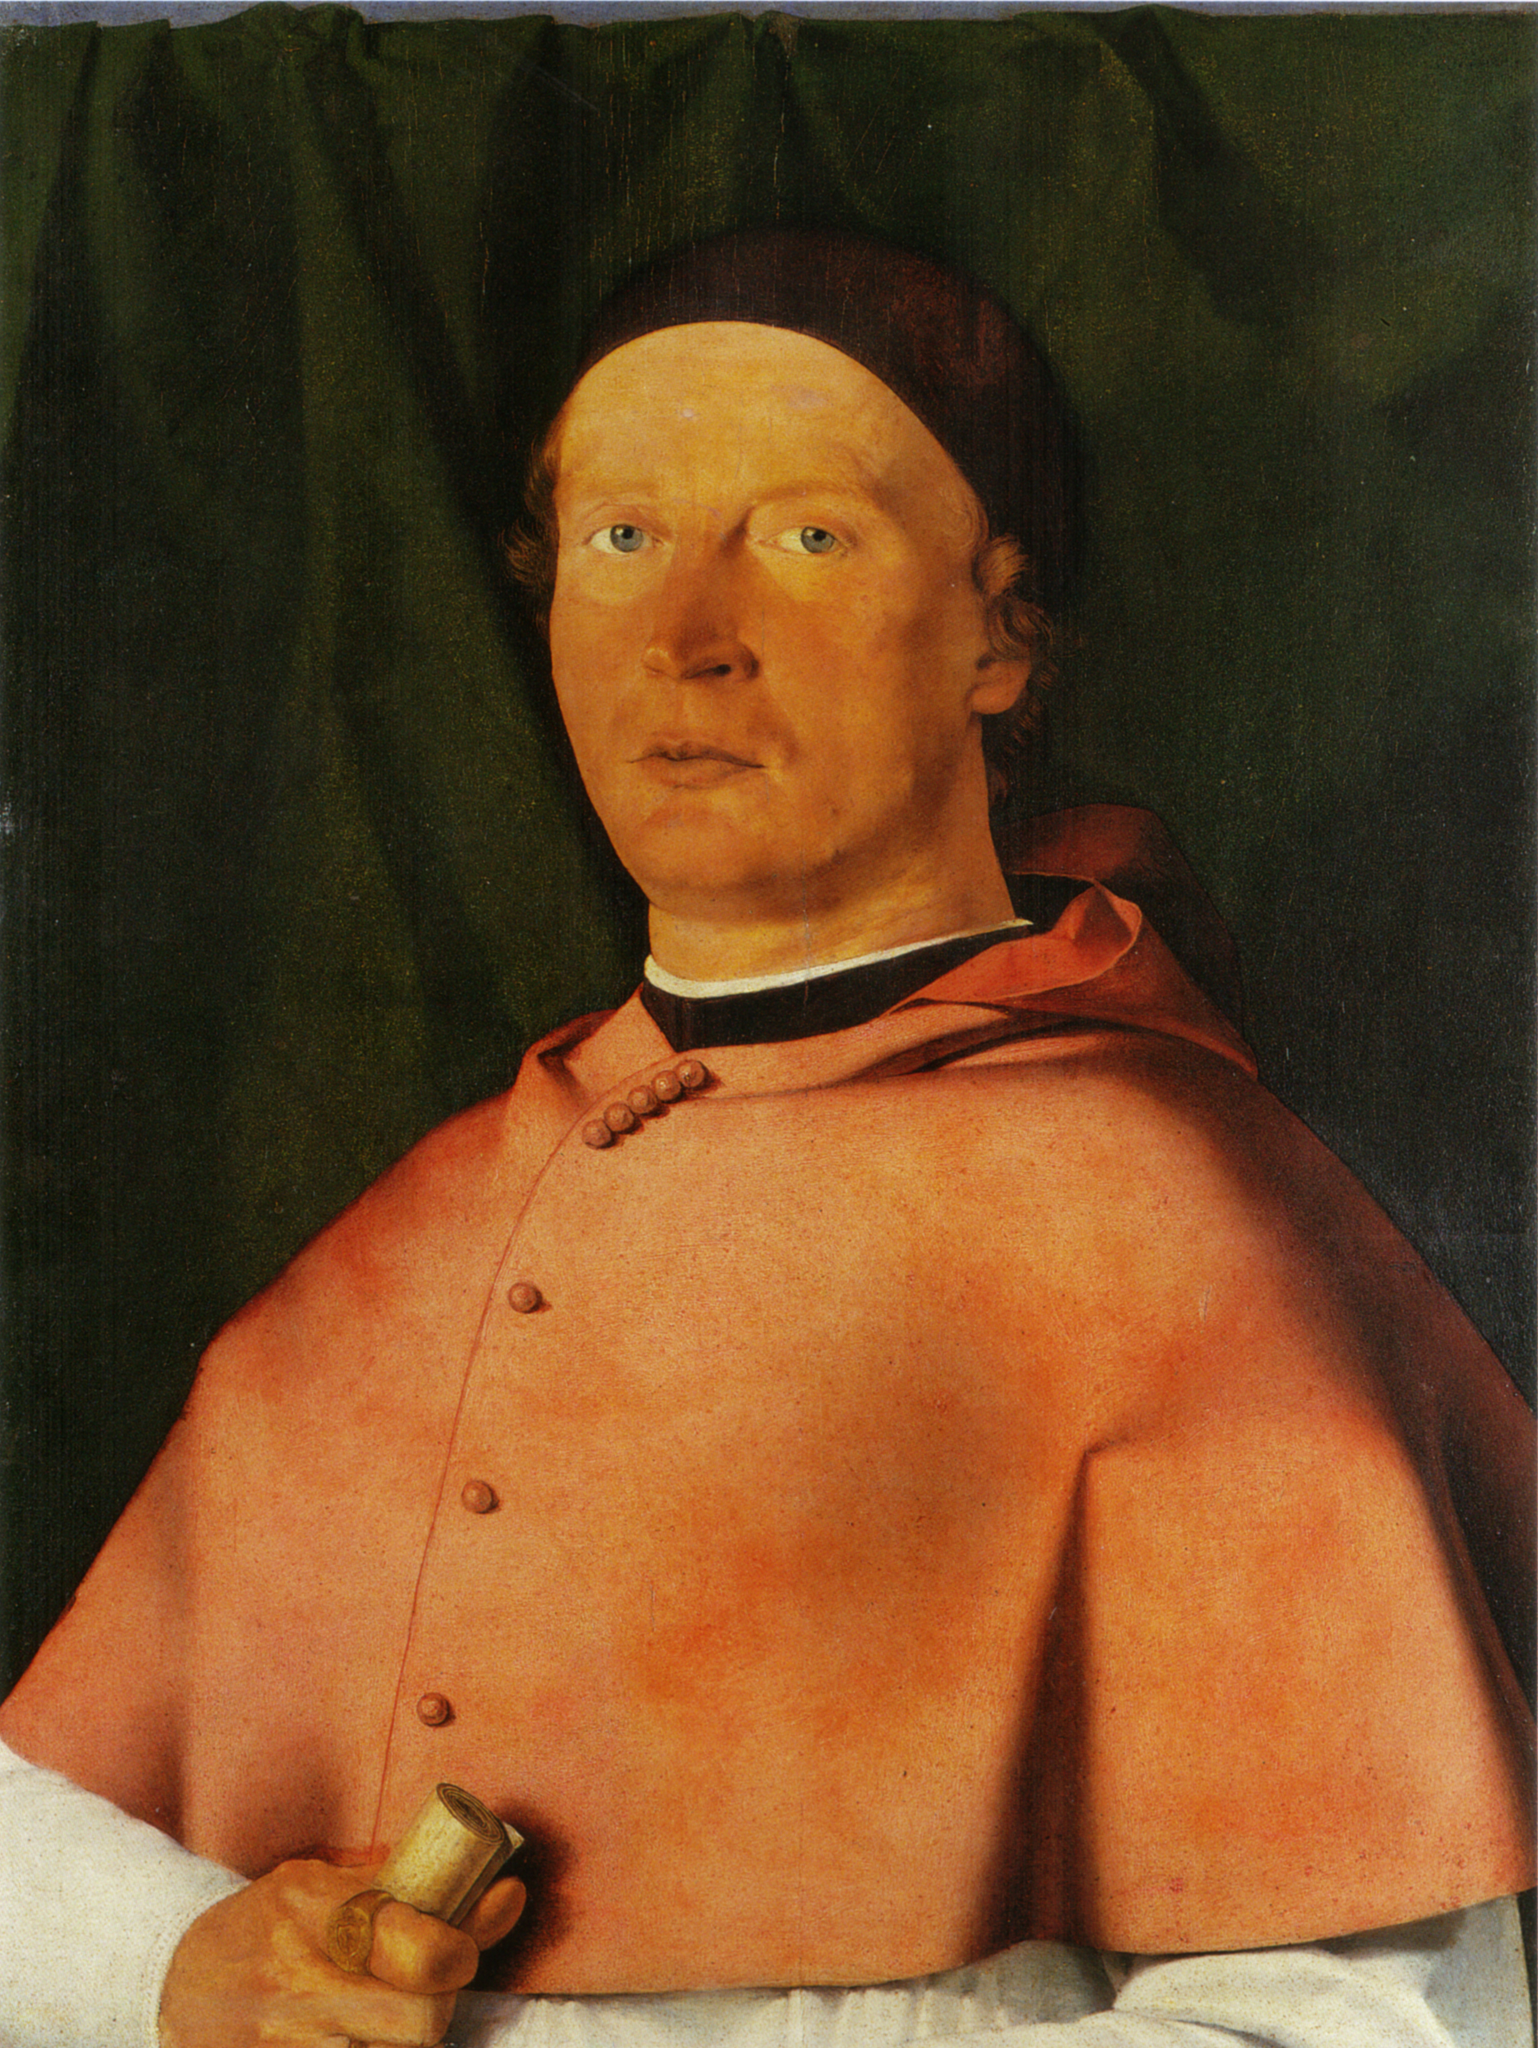Can you describe the attire of the person in the portrait? The man in the portrait is dressed in what appears to be a formal, possibly ceremonial robe of a vibrant red color. The robe covers his shoulders and features a detailed closure with buttons. He also wears a simple black cap, adding to the formality of his attire. His overall clothing suggests he might be a figure of importance, possibly within the church, academia, or a governmental position. 